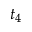Convert formula to latex. <formula><loc_0><loc_0><loc_500><loc_500>t _ { 4 }</formula> 